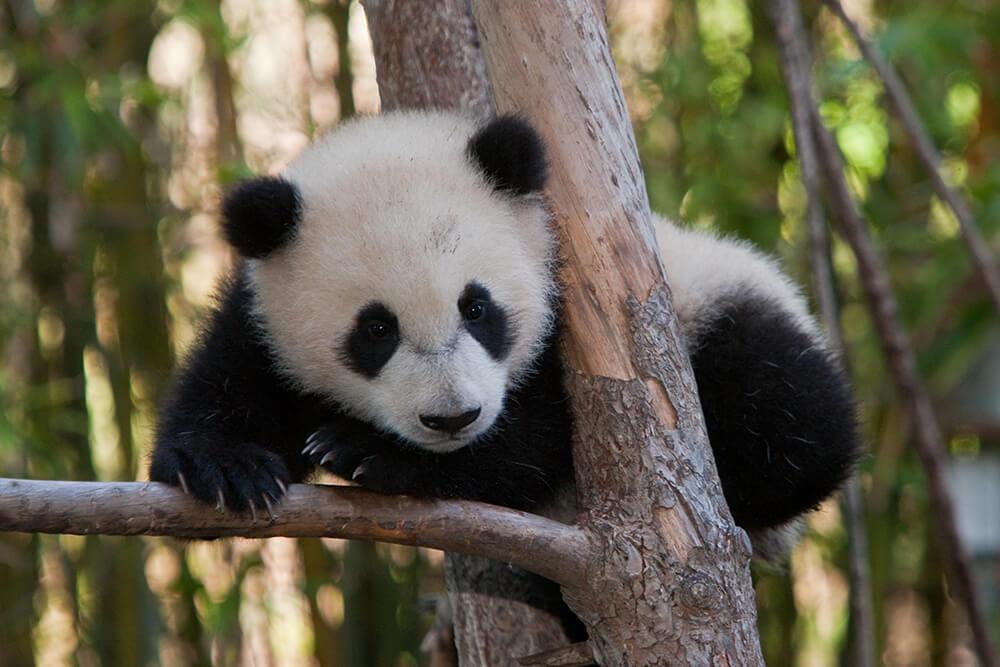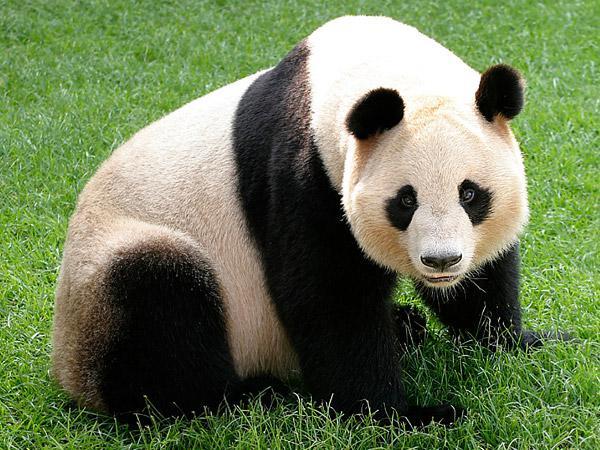The first image is the image on the left, the second image is the image on the right. Assess this claim about the two images: "An image features a panda holding something to its mouth and chewing it.". Correct or not? Answer yes or no. No. 